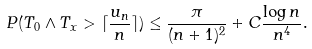<formula> <loc_0><loc_0><loc_500><loc_500>P ( T _ { 0 } \wedge T _ { x } > \lceil \frac { u _ { n } } { n } \rceil ) \leq \frac { \pi } { ( n + 1 ) ^ { 2 } } + C \frac { \log n } { n ^ { 4 } } .</formula> 